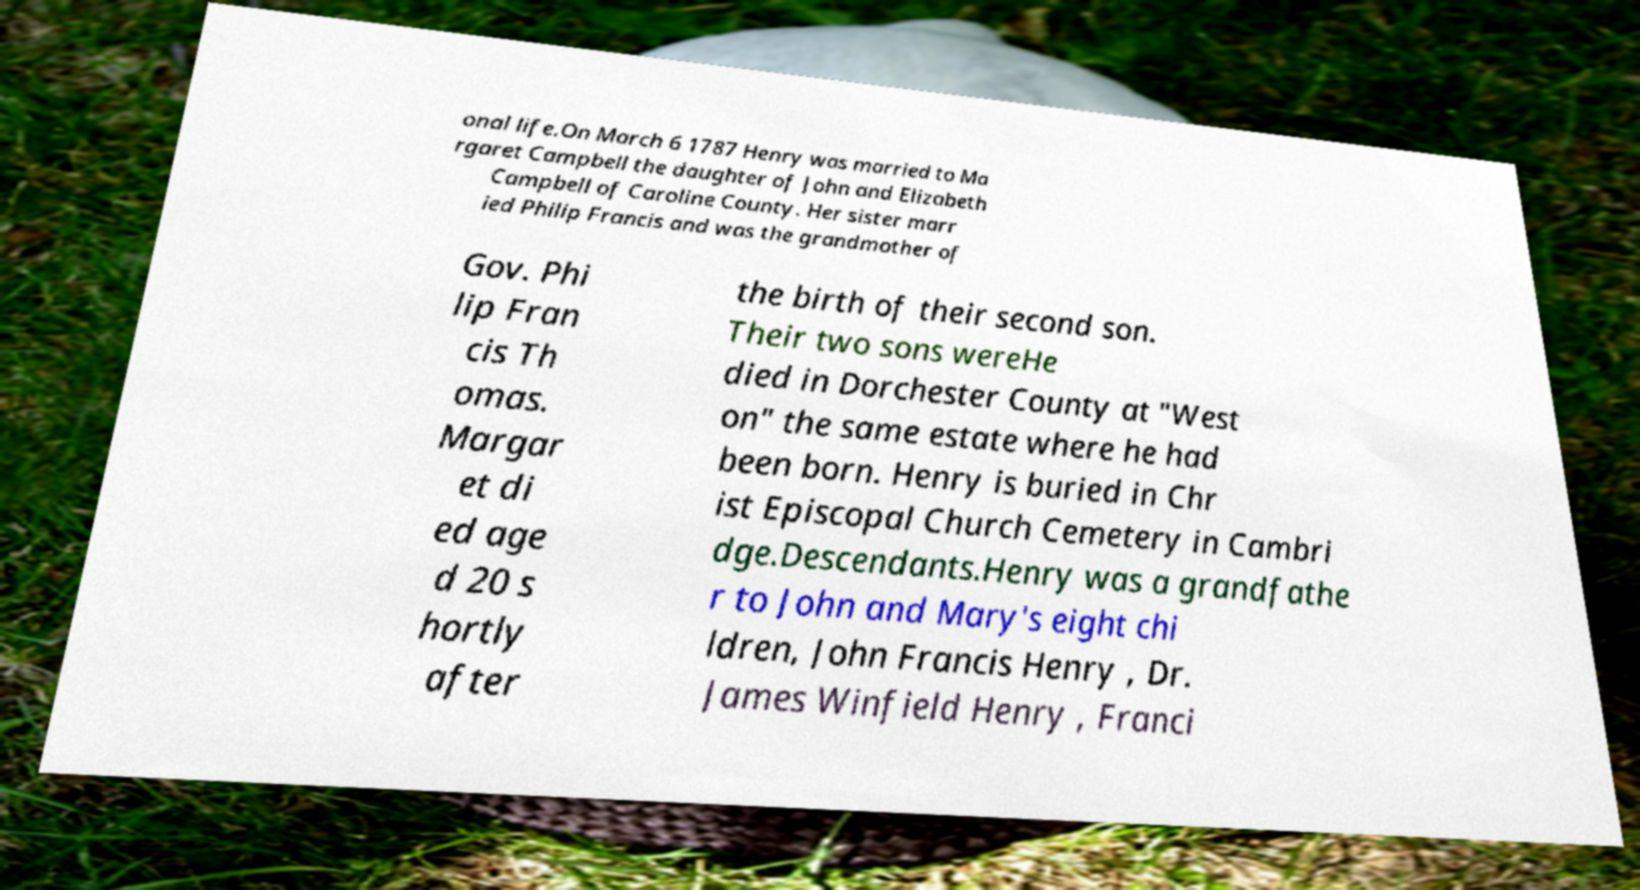I need the written content from this picture converted into text. Can you do that? onal life.On March 6 1787 Henry was married to Ma rgaret Campbell the daughter of John and Elizabeth Campbell of Caroline County. Her sister marr ied Philip Francis and was the grandmother of Gov. Phi lip Fran cis Th omas. Margar et di ed age d 20 s hortly after the birth of their second son. Their two sons wereHe died in Dorchester County at "West on" the same estate where he had been born. Henry is buried in Chr ist Episcopal Church Cemetery in Cambri dge.Descendants.Henry was a grandfathe r to John and Mary's eight chi ldren, John Francis Henry , Dr. James Winfield Henry , Franci 